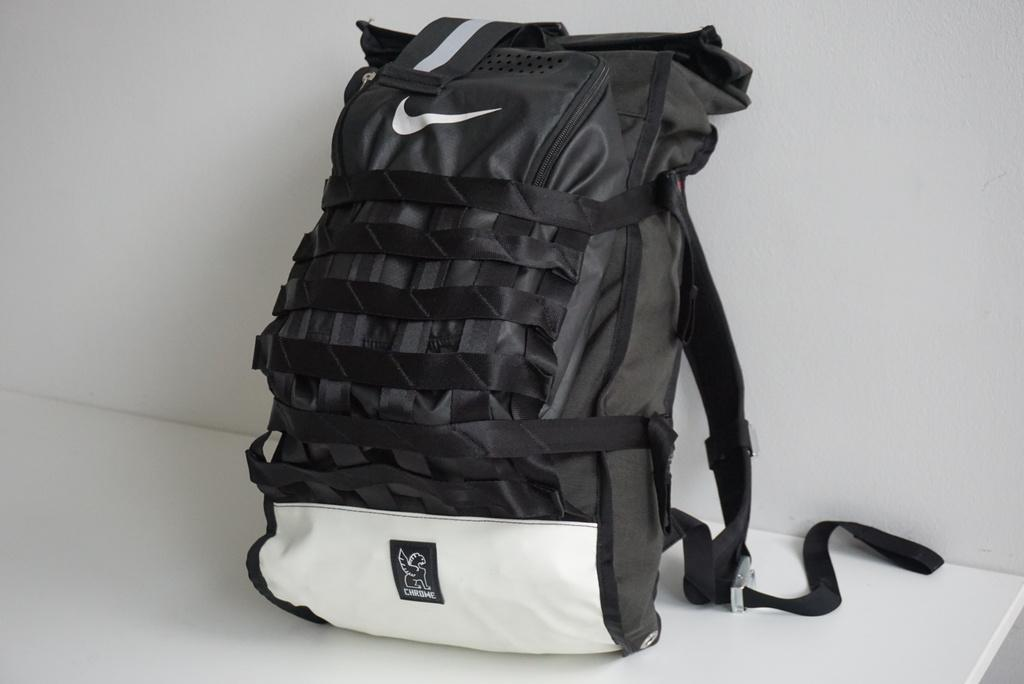What object can be seen in the image? There is a bag in the image. What is the color of the bag? The bag is black in color. What else is visible in the image besides the bag? There is a wall in the image. Is the bag made of glass in the image? No, the bag is not made of glass in the image. The bag is black, and there is no indication that it is made of glass. 